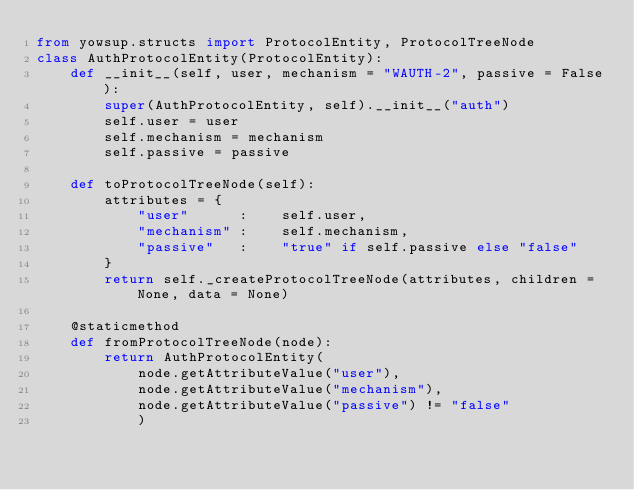<code> <loc_0><loc_0><loc_500><loc_500><_Python_>from yowsup.structs import ProtocolEntity, ProtocolTreeNode
class AuthProtocolEntity(ProtocolEntity):
    def __init__(self, user, mechanism = "WAUTH-2", passive = False):
        super(AuthProtocolEntity, self).__init__("auth")
        self.user = user
        self.mechanism = mechanism
        self.passive = passive
    
    def toProtocolTreeNode(self):
        attributes = {
            "user"      :    self.user,
            "mechanism" :    self.mechanism,
            "passive"   :    "true" if self.passive else "false"
        }
        return self._createProtocolTreeNode(attributes, children = None, data = None)

    @staticmethod
    def fromProtocolTreeNode(node):
        return AuthProtocolEntity(
            node.getAttributeValue("user"),
            node.getAttributeValue("mechanism"),
            node.getAttributeValue("passive") != "false"
            )</code> 